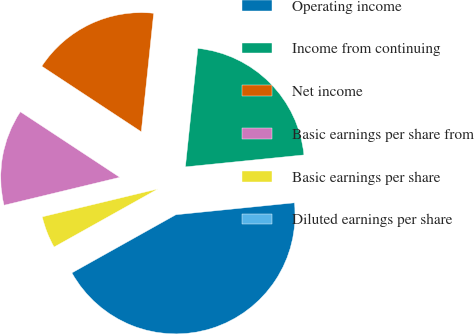Convert chart. <chart><loc_0><loc_0><loc_500><loc_500><pie_chart><fcel>Operating income<fcel>Income from continuing<fcel>Net income<fcel>Basic earnings per share from<fcel>Basic earnings per share<fcel>Diluted earnings per share<nl><fcel>43.48%<fcel>21.74%<fcel>17.39%<fcel>13.04%<fcel>4.35%<fcel>0.0%<nl></chart> 